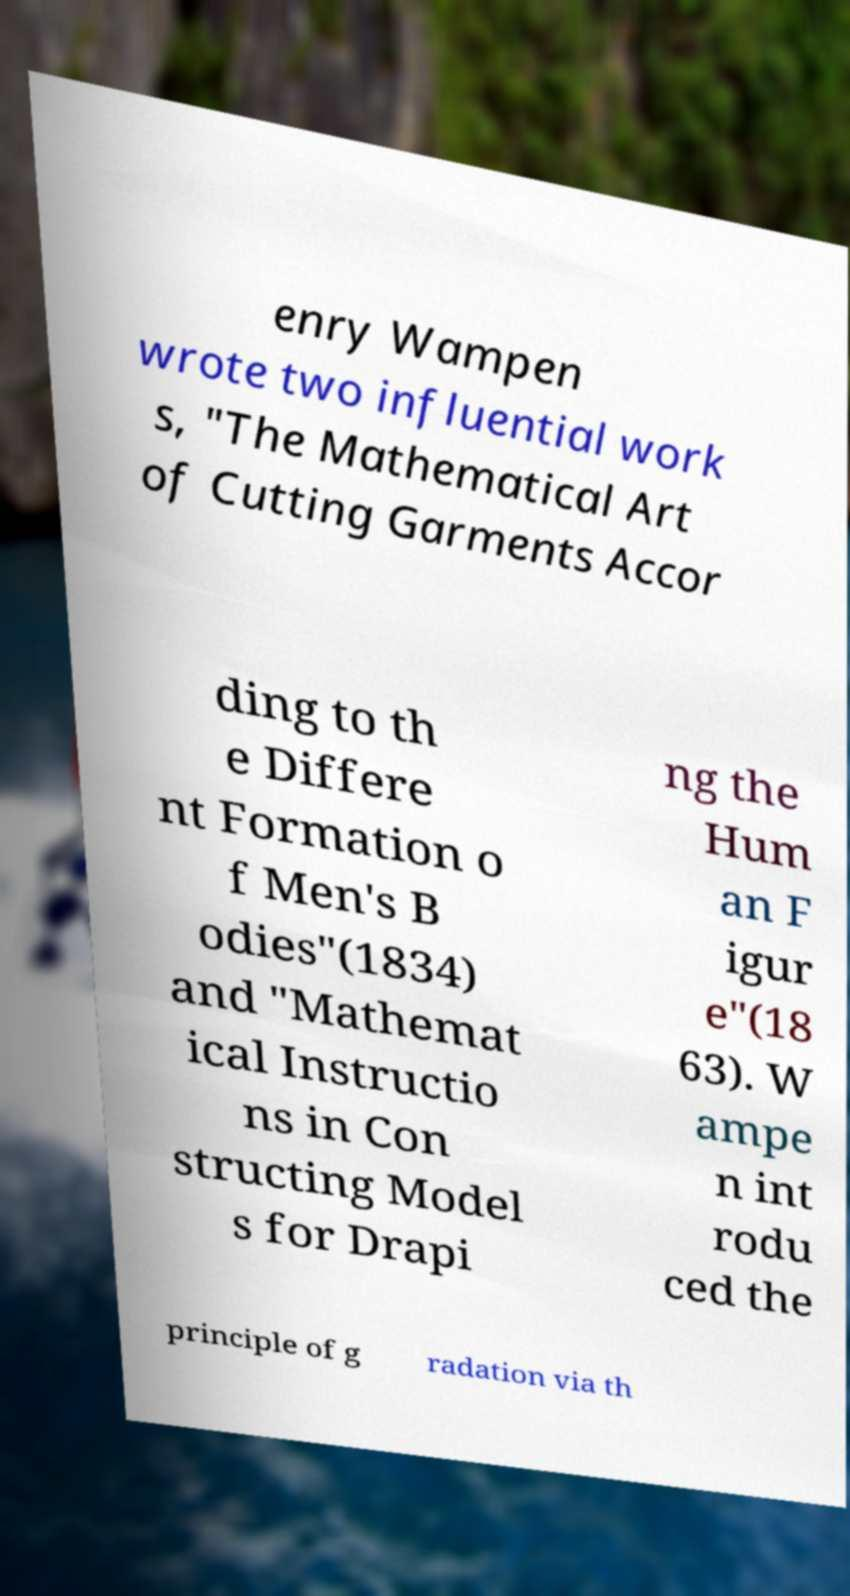What messages or text are displayed in this image? I need them in a readable, typed format. enry Wampen wrote two influential work s, "The Mathematical Art of Cutting Garments Accor ding to th e Differe nt Formation o f Men's B odies"(1834) and "Mathemat ical Instructio ns in Con structing Model s for Drapi ng the Hum an F igur e"(18 63). W ampe n int rodu ced the principle of g radation via th 